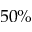<formula> <loc_0><loc_0><loc_500><loc_500>5 0 \%</formula> 